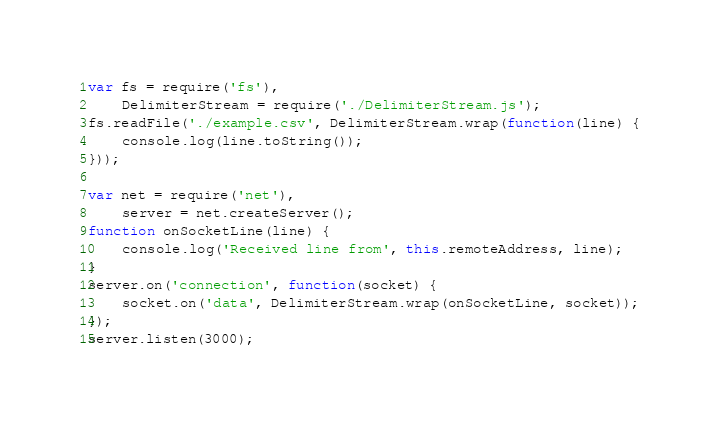<code> <loc_0><loc_0><loc_500><loc_500><_JavaScript_>var fs = require('fs'),
    DelimiterStream = require('./DelimiterStream.js');
fs.readFile('./example.csv', DelimiterStream.wrap(function(line) {
    console.log(line.toString());
}));

var net = require('net'),
    server = net.createServer();
function onSocketLine(line) {
    console.log('Received line from', this.remoteAddress, line);
}
server.on('connection', function(socket) {
    socket.on('data', DelimiterStream.wrap(onSocketLine, socket));
});
server.listen(3000);
</code> 